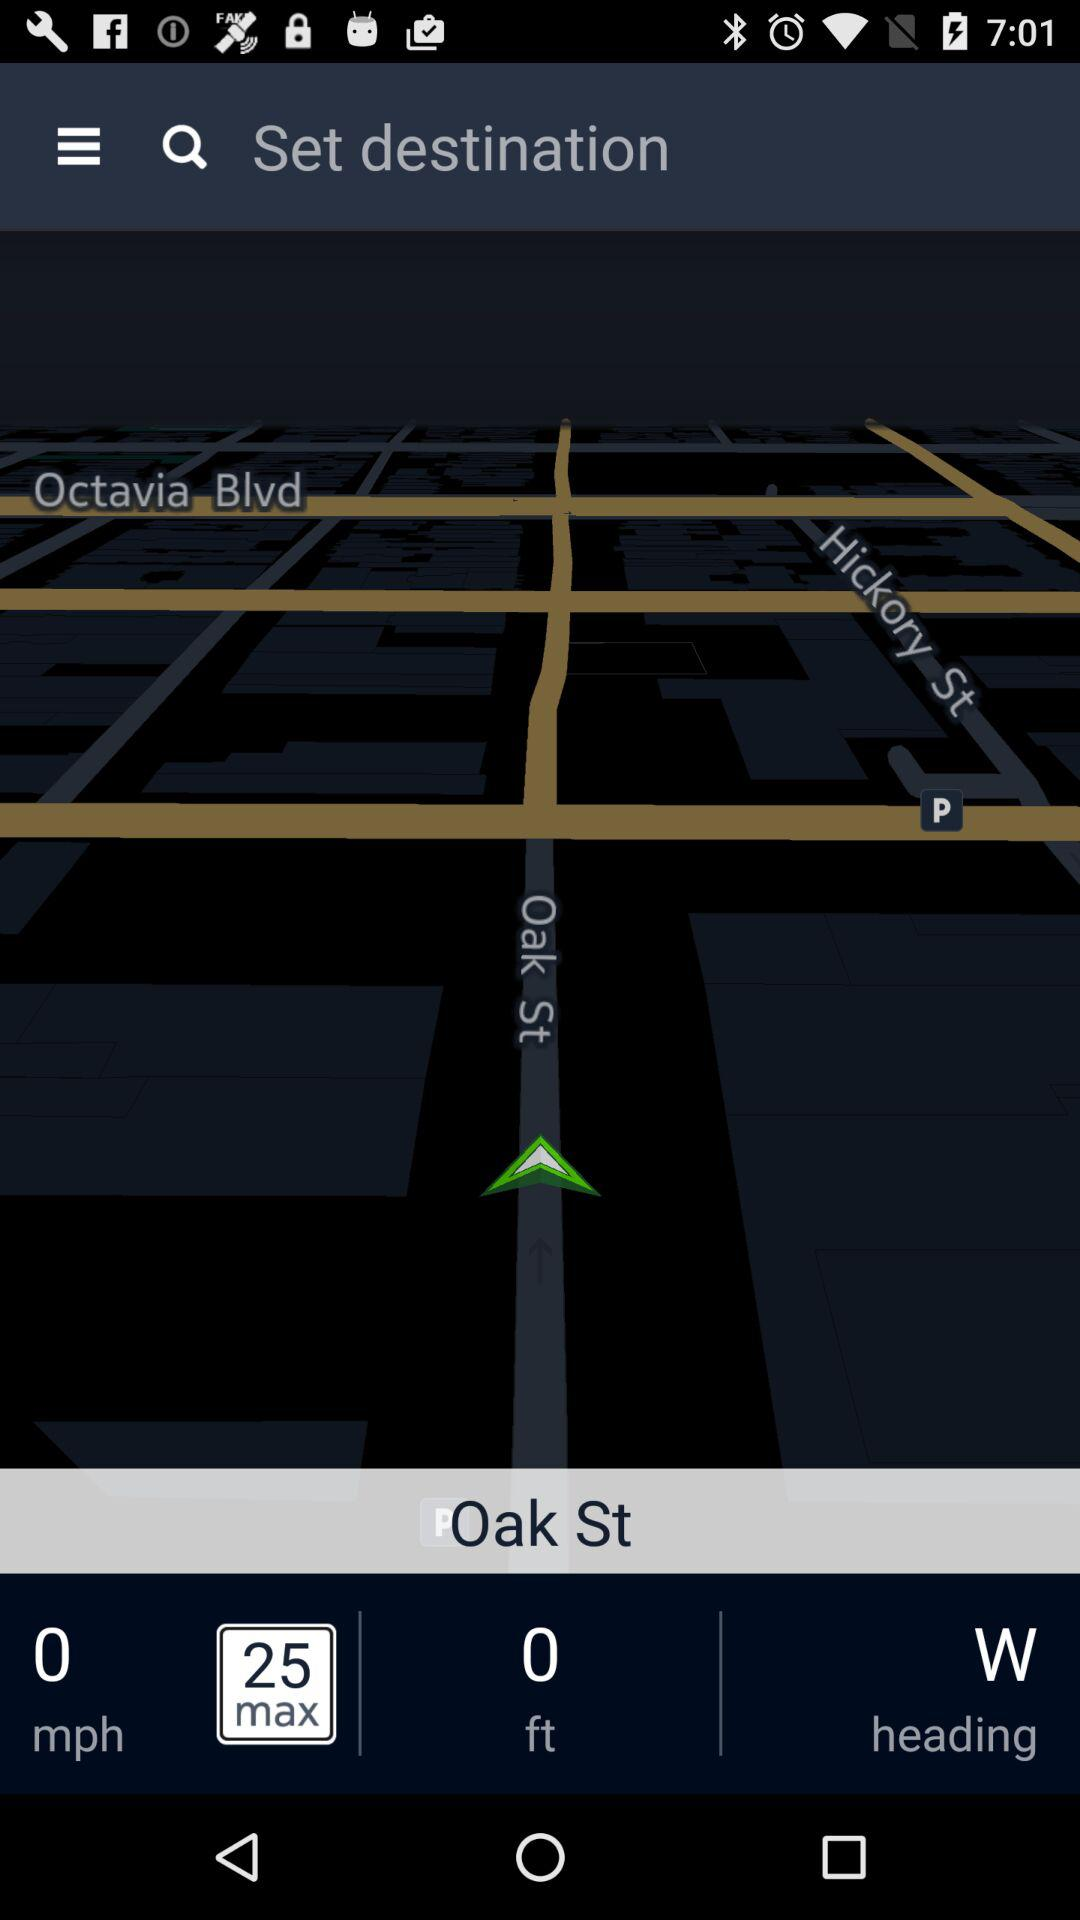What is the speed limit?
Answer the question using a single word or phrase. 25 mph 